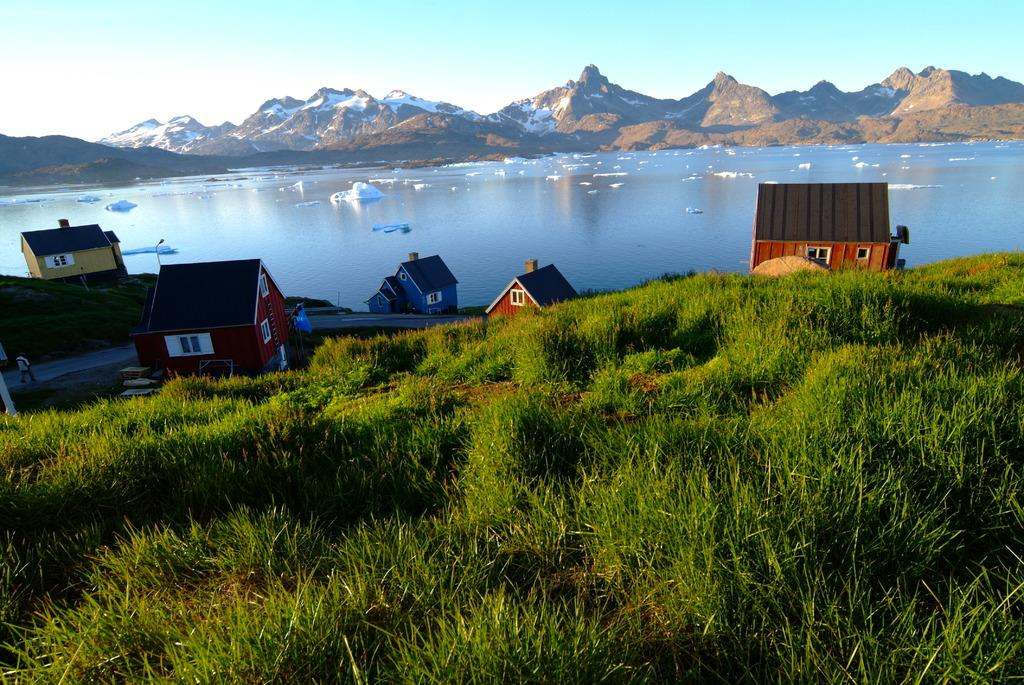What can be seen in the foreground of the image? In the foreground of the image, there is grass, houses, and a road. What is happening on the road in the image? A person is walking on the road in the image. What can be seen in the background of the image? In the background of the image, there is water, ice, mountains, and the sky. What activity is the ice feeling in the image? There is no activity or feeling associated with the ice in the image; it is a static element in the background. What desire does the water have in the image? There is no indication of any desires or emotions associated with the water in the image; it is a natural element in the background. 